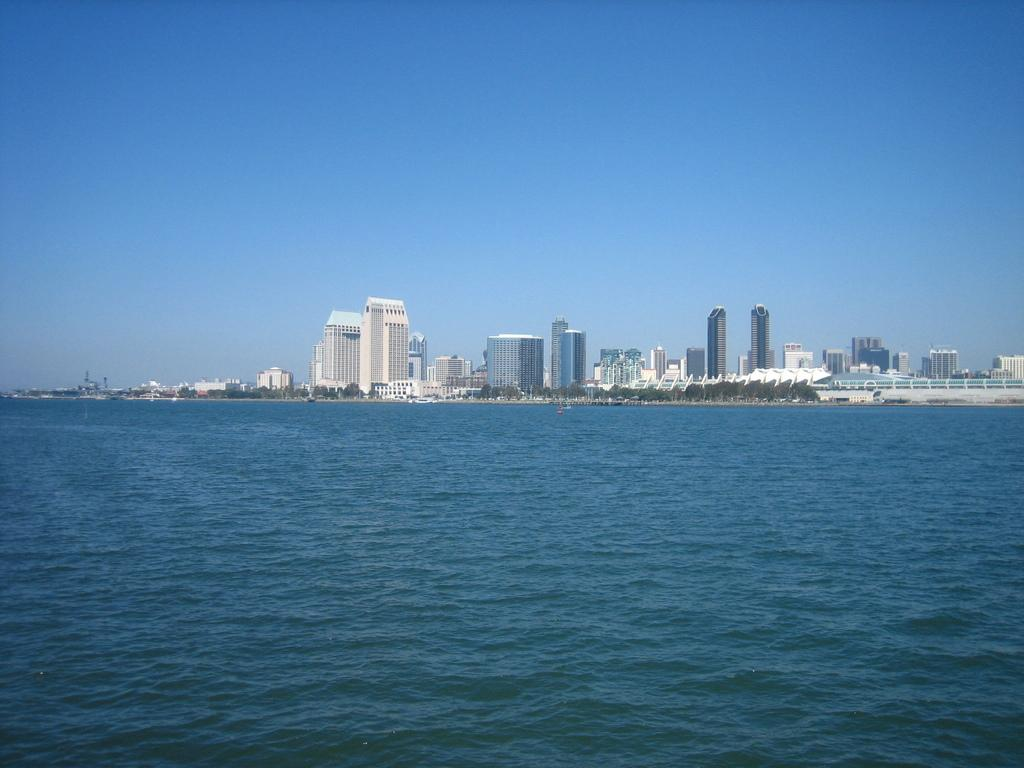What type of structures are present in the image? There are skyscrapers and buildings in the image. What natural elements can be seen in the image? Trees are visible in the image, and there is a body of water (possibly a sea) with water flowing in it. What part of the natural environment is visible in the image? The sky is visible in the image. What type of boot is being worn by the love in the image? There is no love or boot present in the image; it features skyscrapers, buildings, trees, a body of water, and the sky. 